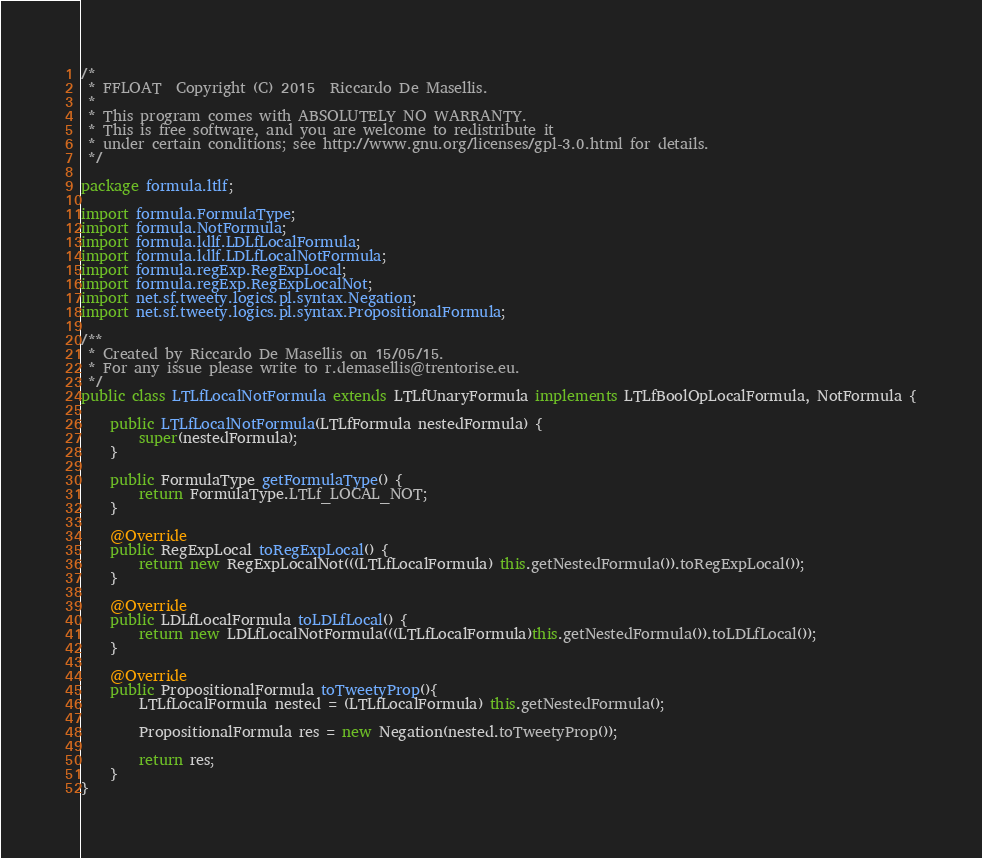Convert code to text. <code><loc_0><loc_0><loc_500><loc_500><_Java_>/*
 * FFLOAT  Copyright (C) 2015  Riccardo De Masellis.
 *
 * This program comes with ABSOLUTELY NO WARRANTY.
 * This is free software, and you are welcome to redistribute it
 * under certain conditions; see http://www.gnu.org/licenses/gpl-3.0.html for details.
 */

package formula.ltlf;

import formula.FormulaType;
import formula.NotFormula;
import formula.ldlf.LDLfLocalFormula;
import formula.ldlf.LDLfLocalNotFormula;
import formula.regExp.RegExpLocal;
import formula.regExp.RegExpLocalNot;
import net.sf.tweety.logics.pl.syntax.Negation;
import net.sf.tweety.logics.pl.syntax.PropositionalFormula;

/**
 * Created by Riccardo De Masellis on 15/05/15.
 * For any issue please write to r.demasellis@trentorise.eu.
 */
public class LTLfLocalNotFormula extends LTLfUnaryFormula implements LTLfBoolOpLocalFormula, NotFormula {

    public LTLfLocalNotFormula(LTLfFormula nestedFormula) {
        super(nestedFormula);
    }

    public FormulaType getFormulaType() {
        return FormulaType.LTLf_LOCAL_NOT;
    }

    @Override
    public RegExpLocal toRegExpLocal() {
        return new RegExpLocalNot(((LTLfLocalFormula) this.getNestedFormula()).toRegExpLocal());
    }

    @Override
    public LDLfLocalFormula toLDLfLocal() {
        return new LDLfLocalNotFormula(((LTLfLocalFormula)this.getNestedFormula()).toLDLfLocal());
    }

    @Override
	public PropositionalFormula toTweetyProp(){
		LTLfLocalFormula nested = (LTLfLocalFormula) this.getNestedFormula();

		PropositionalFormula res = new Negation(nested.toTweetyProp());

		return res;
	}
}
</code> 